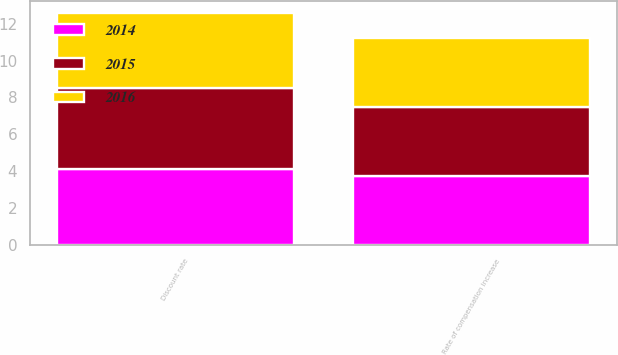Convert chart to OTSL. <chart><loc_0><loc_0><loc_500><loc_500><stacked_bar_chart><ecel><fcel>Discount rate<fcel>Rate of compensation increase<nl><fcel>2016<fcel>4.1<fcel>3.75<nl><fcel>2015<fcel>4.4<fcel>3.75<nl><fcel>2014<fcel>4.1<fcel>3.75<nl></chart> 